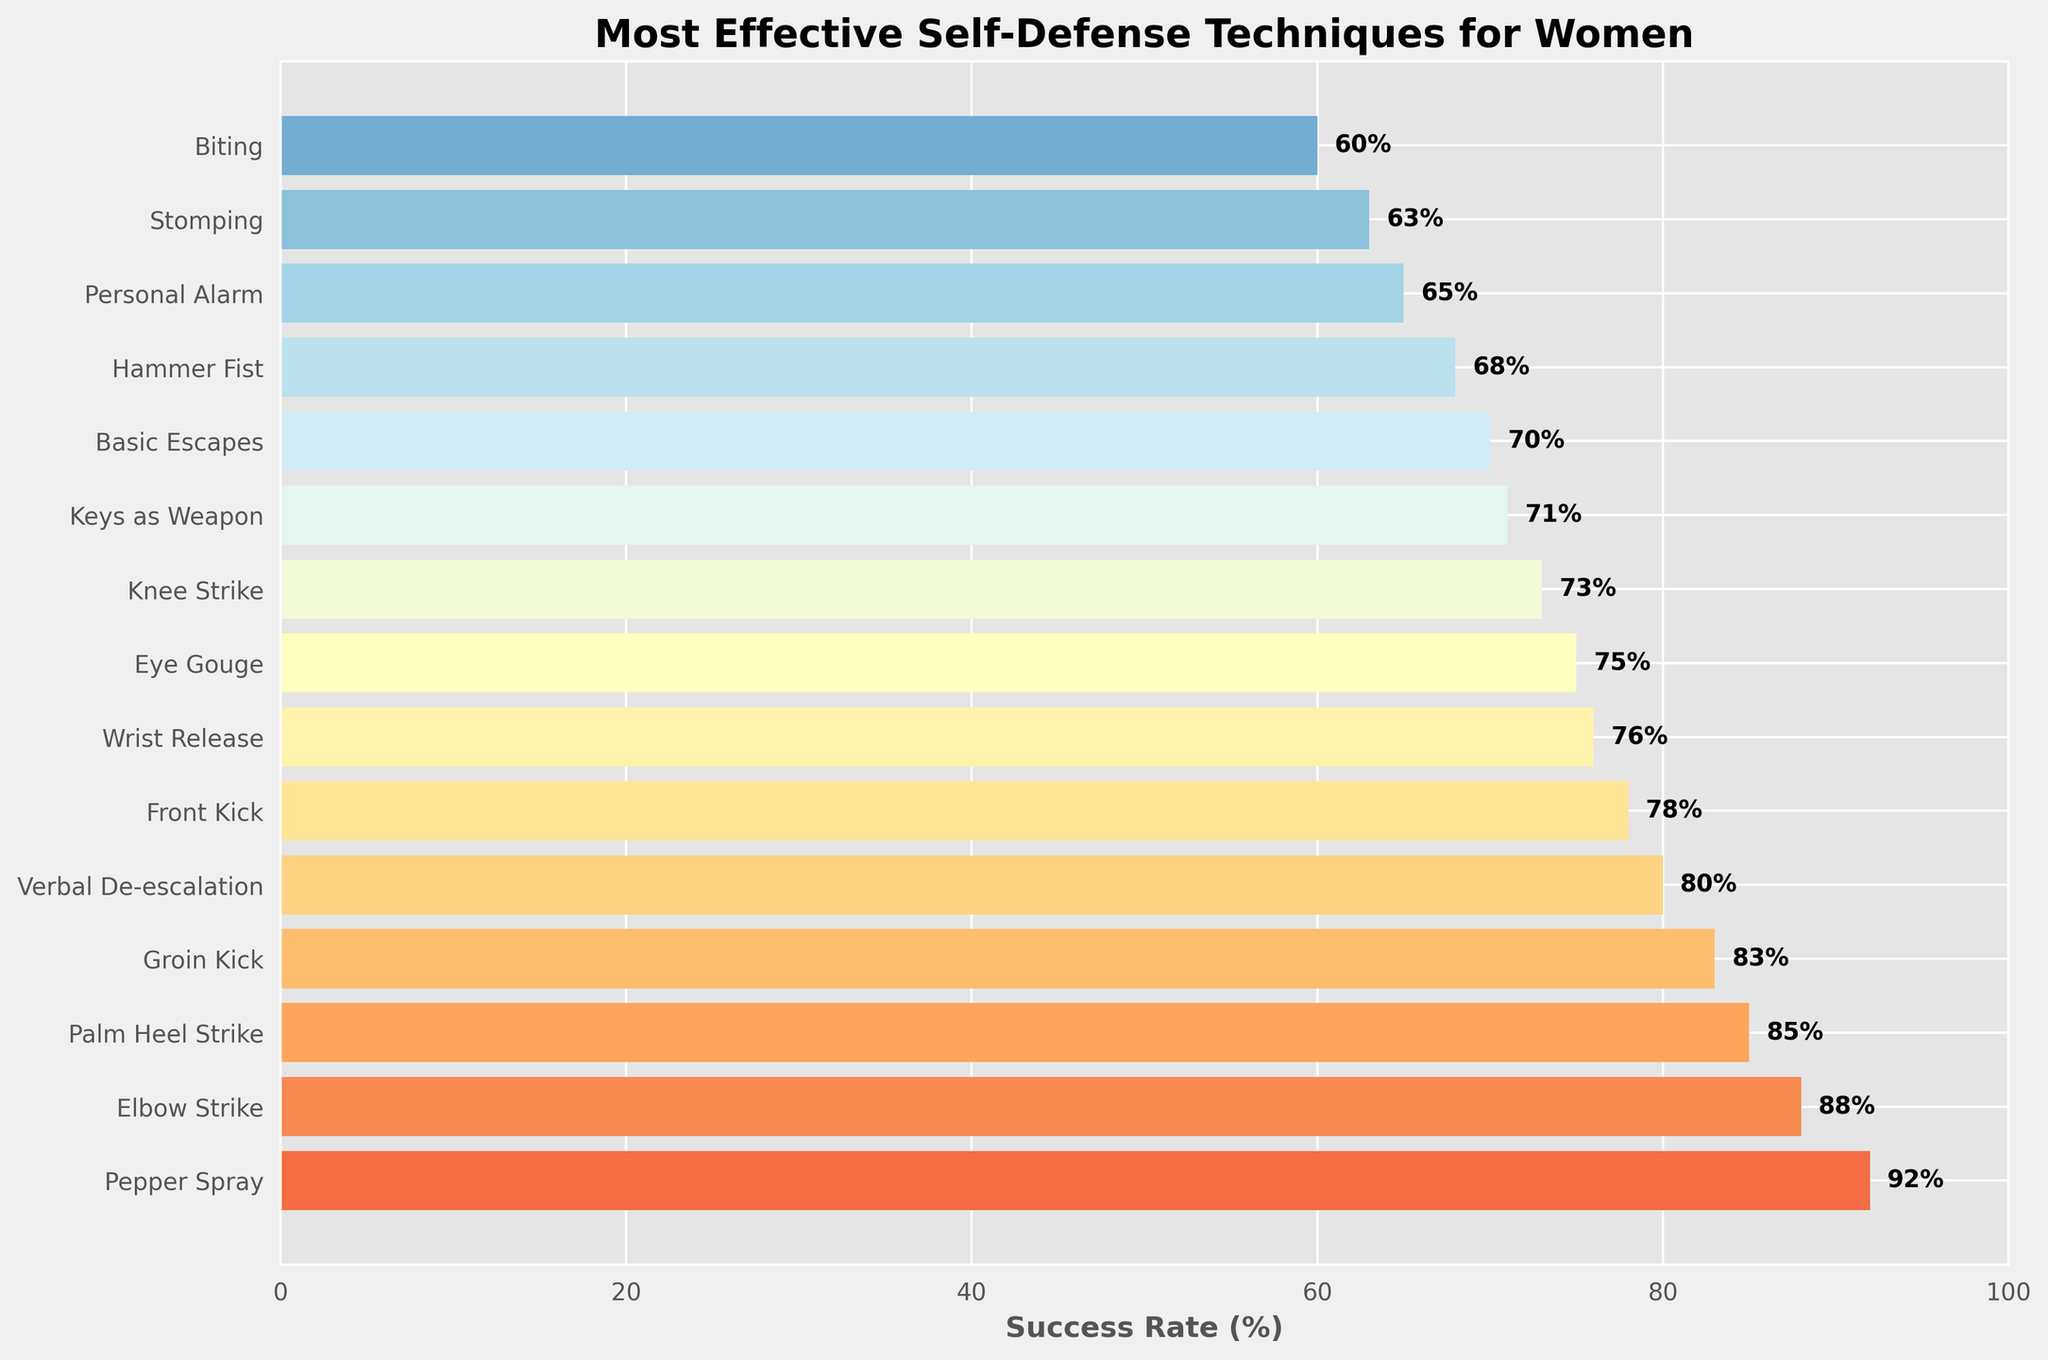What's the highest success rate technique according to the chart? The highest bar on the chart represents the technique with the highest success rate. In this case, it's "Pepper Spray" with a success rate of 92%.
Answer: Pepper Spray Which technique has a lower success rate, "Wrist Release" or "Keys as Weapon"? Compare the lengths of the bars corresponding to these two techniques. The "Keys as Weapon" bar is shorter than the "Wrist Release" bar, indicating a lower success rate (71% vs. 76%).
Answer: Keys as Weapon What is the total success rate of the top three techniques combined? The top three techniques are "Pepper Spray" (92%), "Elbow Strike" (88%), and "Palm Heel Strike" (85%). Summing their success rates: 92 + 88 + 85 = 265.
Answer: 265 Which technique has a success rate closest to 80%? By observing the success rates in the chart, "Verbal De-escalation" has the closest success rate to 80%, exactly at 80%.
Answer: Verbal De-escalation Is "Knee Strike" more or less effective than "Basic Escapes"? By comparing the bars, "Knee Strike" has a success rate of 73%, which is higher than "Basic Escapes" with a success rate of 70%.
Answer: More effective What is the difference in success rate between "Eye Gouge" and "Hammer Fist"? "Eye Gouge" has a success rate of 75%, while "Hammer Fist" has 68%. The difference is 75 - 68 = 7%.
Answer: 7% How many techniques have a success rate above 80%? Count the number of bars with a success rate higher than 80%. They are "Pepper Spray" (92%), "Elbow Strike" (88%), "Palm Heel Strike" (85%), "Groin Kick" (83%), and "Verbal De-escalation" (80%). Total: 5 techniques.
Answer: 5 What is the least effective technique shown in the chart? The shortest bar represents the technique with the lowest success rate, which is "Biting" with a success rate of 60%.
Answer: Biting Which technique has a higher success rate, "Front Kick" or "Groin Kick"? Compare the bars for these two techniques. "Groin Kick" (83%) has a higher success rate than "Front Kick" (78%).
Answer: Groin Kick Are more than half of the techniques above a 70% success rate? There are 16 techniques in total. Counting the number of techniques with a success rate above 70%, which are 9 ("Pepper Spray", "Elbow Strike", "Palm Heel Strike", "Groin Kick", "Verbal De-escalation", "Front Kick", "Wrist Release", "Eye Gouge", and "Knee Strike"). 9 out of 16 is more than half.
Answer: Yes 